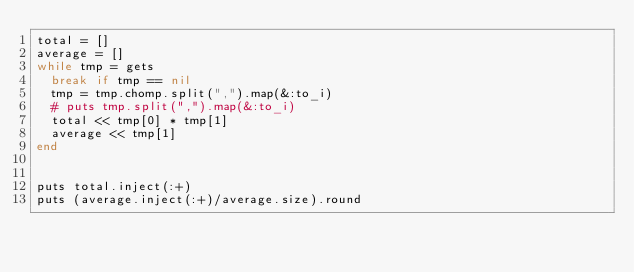<code> <loc_0><loc_0><loc_500><loc_500><_Ruby_>total = []
average = []
while tmp = gets
  break if tmp == nil
  tmp = tmp.chomp.split(",").map(&:to_i)
  # puts tmp.split(",").map(&:to_i)
  total << tmp[0] * tmp[1]
  average << tmp[1]
end


puts total.inject(:+)
puts (average.inject(:+)/average.size).round

</code> 